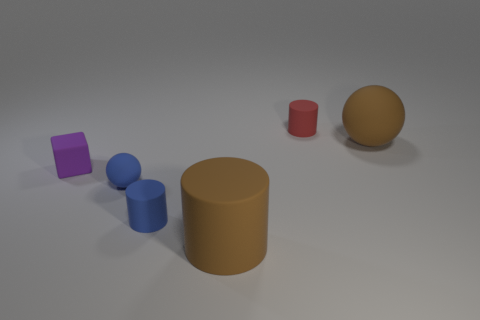Is there any other thing that has the same shape as the tiny purple thing?
Your answer should be very brief. No. What color is the small sphere that is the same material as the small purple thing?
Keep it short and to the point. Blue. How many other big objects are made of the same material as the purple thing?
Your answer should be compact. 2. There is a large matte sphere; does it have the same color as the large matte object that is in front of the big brown rubber ball?
Make the answer very short. Yes. There is a tiny matte cylinder that is in front of the big object behind the small blue matte cylinder; what color is it?
Ensure brevity in your answer.  Blue. There is a cube that is the same size as the red object; what is its color?
Your response must be concise. Purple. Are there any small blue matte things of the same shape as the small red rubber object?
Ensure brevity in your answer.  Yes. What is the shape of the tiny purple rubber object?
Ensure brevity in your answer.  Cube. Is the number of red cylinders that are in front of the tiny purple thing greater than the number of red rubber objects left of the large brown cylinder?
Offer a terse response. No. How many other things are there of the same size as the purple thing?
Your answer should be very brief. 3. 